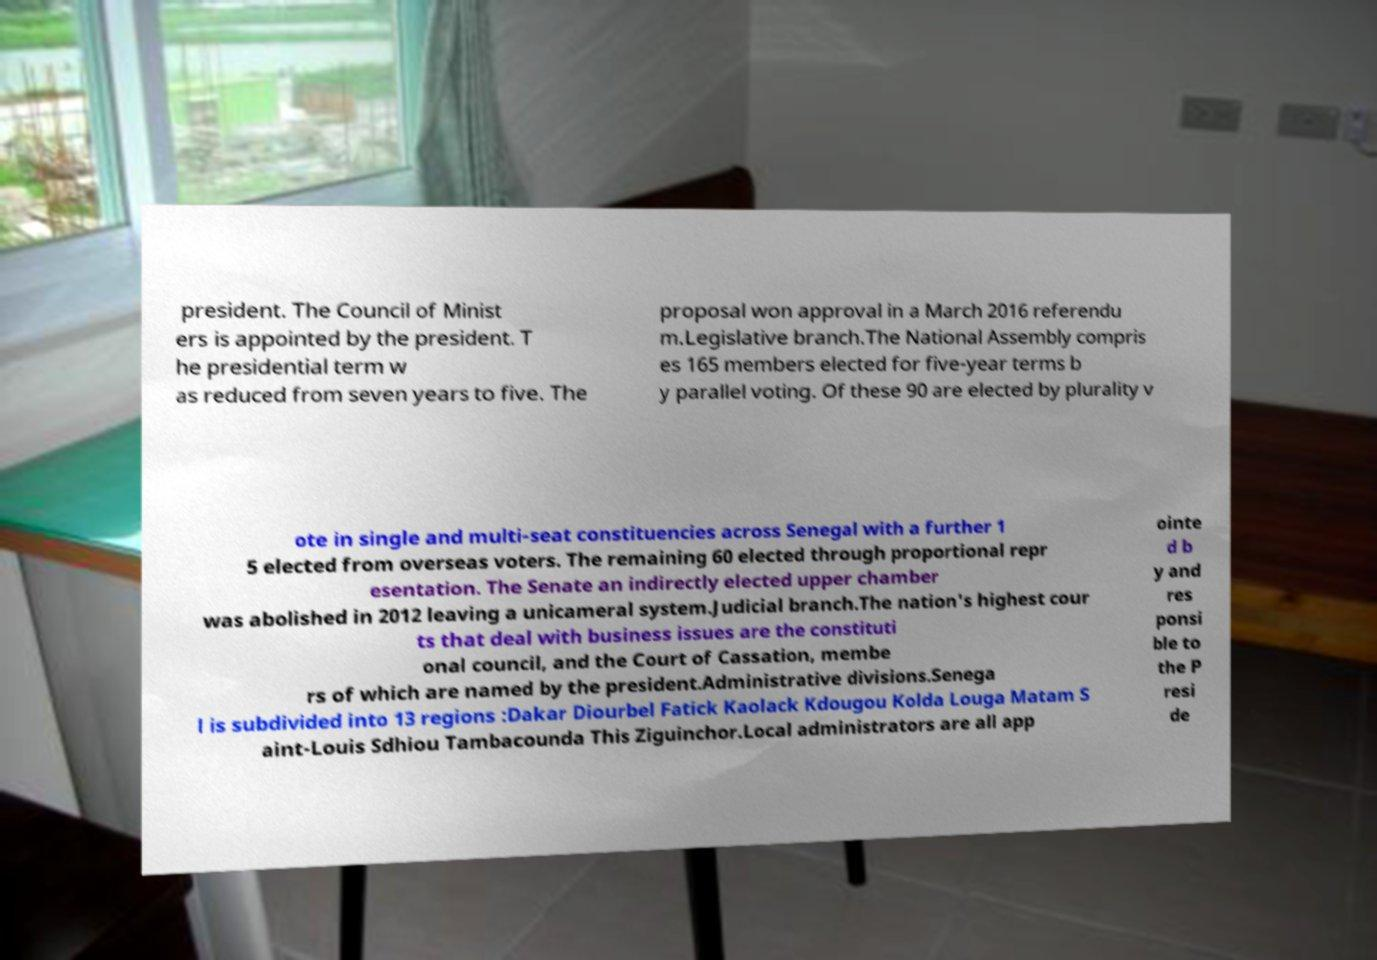Please identify and transcribe the text found in this image. president. The Council of Minist ers is appointed by the president. T he presidential term w as reduced from seven years to five. The proposal won approval in a March 2016 referendu m.Legislative branch.The National Assembly compris es 165 members elected for five-year terms b y parallel voting. Of these 90 are elected by plurality v ote in single and multi-seat constituencies across Senegal with a further 1 5 elected from overseas voters. The remaining 60 elected through proportional repr esentation. The Senate an indirectly elected upper chamber was abolished in 2012 leaving a unicameral system.Judicial branch.The nation's highest cour ts that deal with business issues are the constituti onal council, and the Court of Cassation, membe rs of which are named by the president.Administrative divisions.Senega l is subdivided into 13 regions :Dakar Diourbel Fatick Kaolack Kdougou Kolda Louga Matam S aint-Louis Sdhiou Tambacounda This Ziguinchor.Local administrators are all app ointe d b y and res ponsi ble to the P resi de 